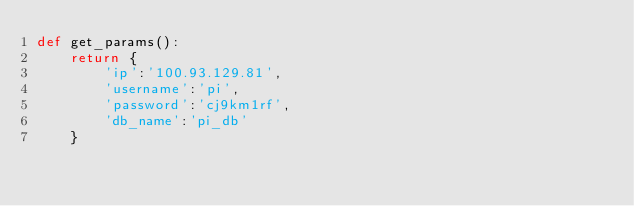<code> <loc_0><loc_0><loc_500><loc_500><_Python_>def get_params():
    return {
        'ip':'100.93.129.81',
        'username':'pi',
        'password':'cj9km1rf',
        'db_name':'pi_db'
    }</code> 